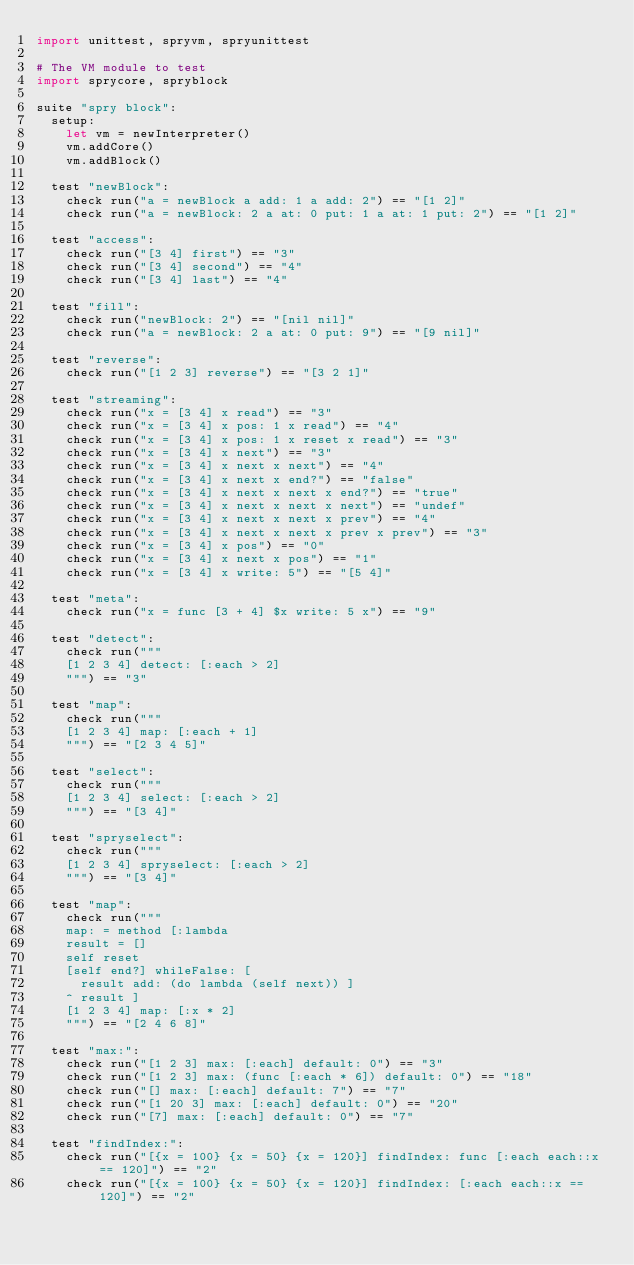<code> <loc_0><loc_0><loc_500><loc_500><_Nim_>import unittest, spryvm, spryunittest

# The VM module to test
import sprycore, spryblock

suite "spry block":
  setup:
    let vm = newInterpreter()
    vm.addCore()
    vm.addBlock()

  test "newBlock":
    check run("a = newBlock a add: 1 a add: 2") == "[1 2]"
    check run("a = newBlock: 2 a at: 0 put: 1 a at: 1 put: 2") == "[1 2]"

  test "access":
    check run("[3 4] first") == "3"
    check run("[3 4] second") == "4"
    check run("[3 4] last") == "4"

  test "fill":
    check run("newBlock: 2") == "[nil nil]"
    check run("a = newBlock: 2 a at: 0 put: 9") == "[9 nil]"

  test "reverse":
    check run("[1 2 3] reverse") == "[3 2 1]"

  test "streaming":
    check run("x = [3 4] x read") == "3"
    check run("x = [3 4] x pos: 1 x read") == "4"
    check run("x = [3 4] x pos: 1 x reset x read") == "3"
    check run("x = [3 4] x next") == "3"
    check run("x = [3 4] x next x next") == "4"
    check run("x = [3 4] x next x end?") == "false"
    check run("x = [3 4] x next x next x end?") == "true"
    check run("x = [3 4] x next x next x next") == "undef"
    check run("x = [3 4] x next x next x prev") == "4"
    check run("x = [3 4] x next x next x prev x prev") == "3"
    check run("x = [3 4] x pos") == "0"
    check run("x = [3 4] x next x pos") == "1"
    check run("x = [3 4] x write: 5") == "[5 4]"

  test "meta":
    check run("x = func [3 + 4] $x write: 5 x") == "9"

  test "detect":
    check run("""
    [1 2 3 4] detect: [:each > 2]
    """) == "3"

  test "map":
    check run("""
    [1 2 3 4] map: [:each + 1]
    """) == "[2 3 4 5]"

  test "select":
    check run("""
    [1 2 3 4] select: [:each > 2]
    """) == "[3 4]"

  test "spryselect":
    check run("""
    [1 2 3 4] spryselect: [:each > 2]
    """) == "[3 4]"

  test "map":
    check run("""
    map: = method [:lambda
    result = []
    self reset
    [self end?] whileFalse: [
      result add: (do lambda (self next)) ]
    ^ result ]
    [1 2 3 4] map: [:x * 2]
    """) == "[2 4 6 8]"

  test "max:":
    check run("[1 2 3] max: [:each] default: 0") == "3"
    check run("[1 2 3] max: (func [:each * 6]) default: 0") == "18"
    check run("[] max: [:each] default: 7") == "7"
    check run("[1 20 3] max: [:each] default: 0") == "20"
    check run("[7] max: [:each] default: 0") == "7"

  test "findIndex:":
    check run("[{x = 100} {x = 50} {x = 120}] findIndex: func [:each each::x == 120]") == "2"
    check run("[{x = 100} {x = 50} {x = 120}] findIndex: [:each each::x == 120]") == "2"
    </code> 